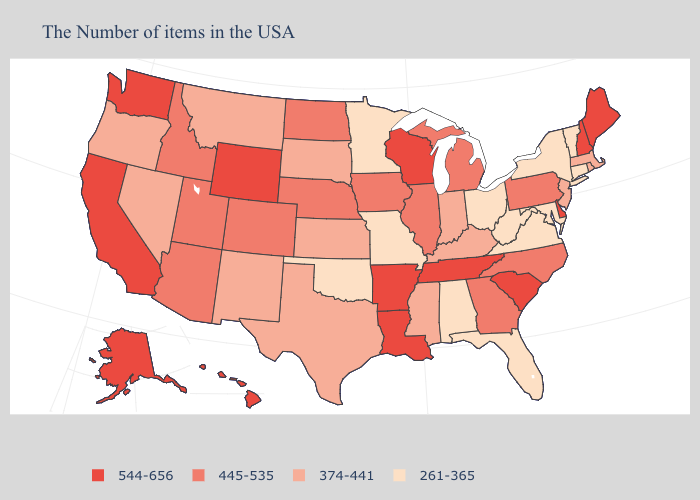What is the lowest value in states that border Virginia?
Write a very short answer. 261-365. Which states have the lowest value in the South?
Write a very short answer. Maryland, Virginia, West Virginia, Florida, Alabama, Oklahoma. Name the states that have a value in the range 445-535?
Concise answer only. Pennsylvania, North Carolina, Georgia, Michigan, Illinois, Iowa, Nebraska, North Dakota, Colorado, Utah, Arizona, Idaho. Which states hav the highest value in the South?
Be succinct. Delaware, South Carolina, Tennessee, Louisiana, Arkansas. Is the legend a continuous bar?
Answer briefly. No. Name the states that have a value in the range 445-535?
Write a very short answer. Pennsylvania, North Carolina, Georgia, Michigan, Illinois, Iowa, Nebraska, North Dakota, Colorado, Utah, Arizona, Idaho. What is the highest value in the South ?
Keep it brief. 544-656. Does Arkansas have a higher value than South Dakota?
Give a very brief answer. Yes. Which states hav the highest value in the Northeast?
Concise answer only. Maine, New Hampshire. What is the highest value in states that border South Dakota?
Be succinct. 544-656. Does Maine have the highest value in the Northeast?
Concise answer only. Yes. What is the lowest value in the West?
Short answer required. 374-441. Name the states that have a value in the range 261-365?
Give a very brief answer. Vermont, Connecticut, New York, Maryland, Virginia, West Virginia, Ohio, Florida, Alabama, Missouri, Minnesota, Oklahoma. 